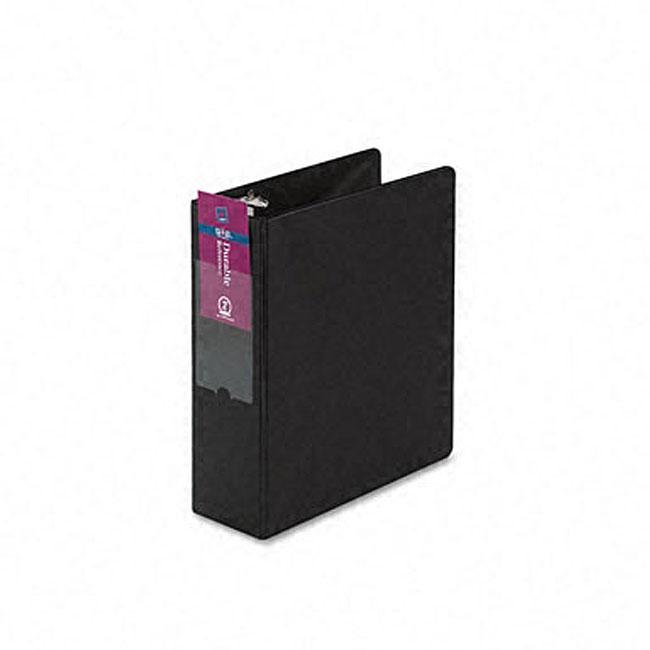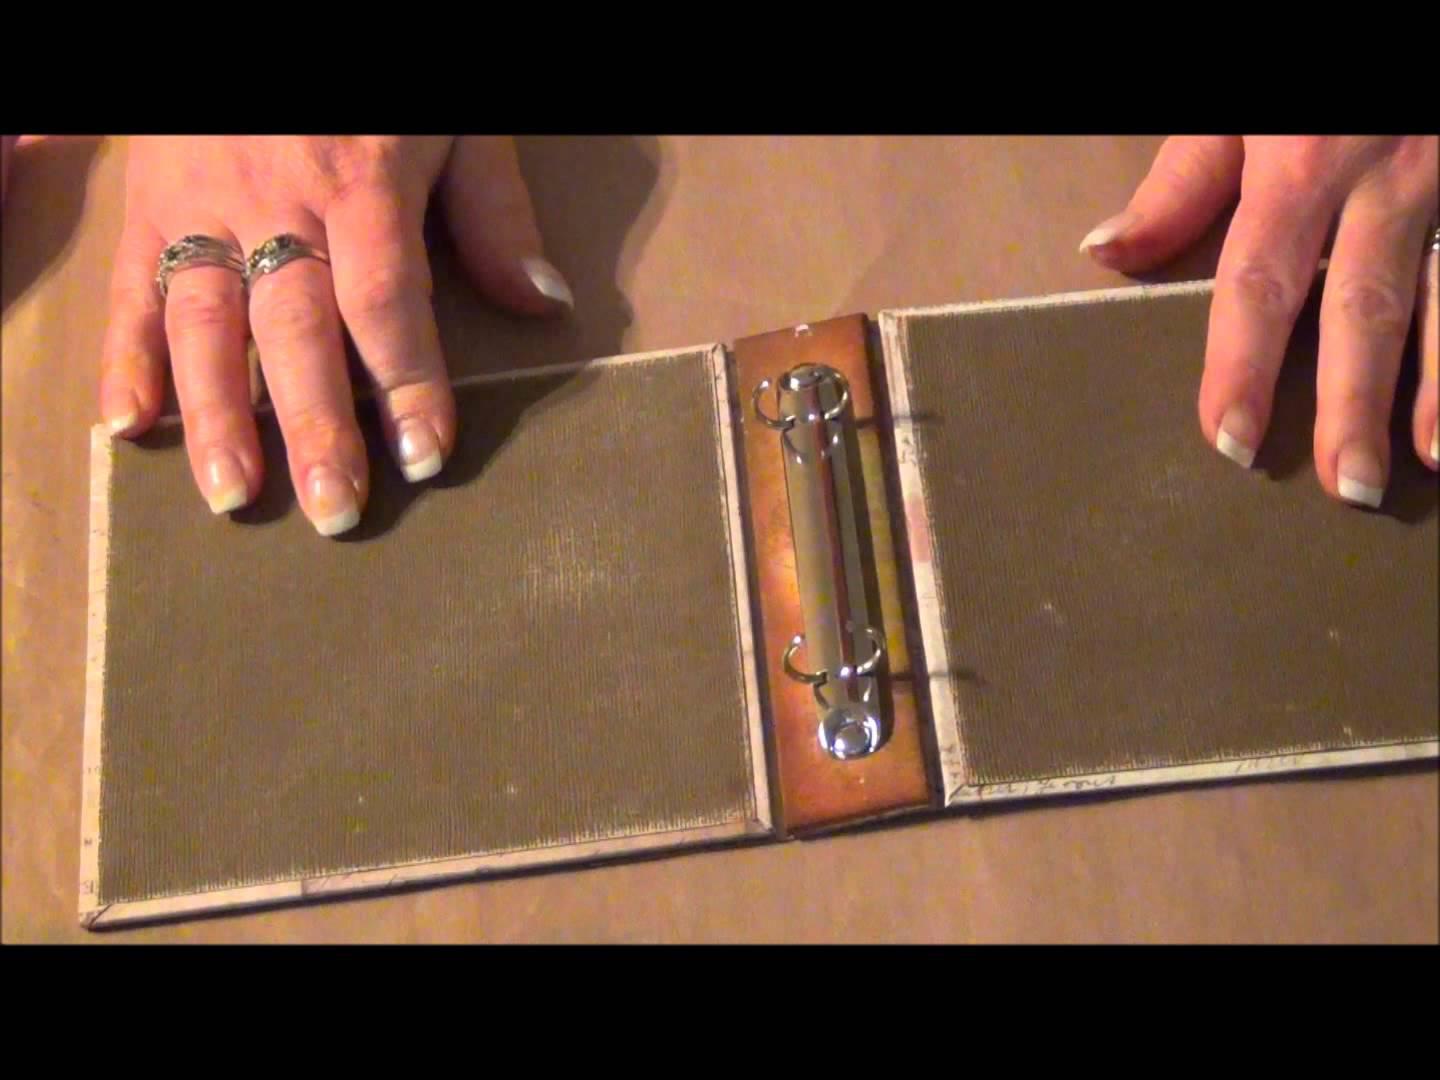The first image is the image on the left, the second image is the image on the right. For the images displayed, is the sentence "An image includes a black upright binder with a black circle below a white rectangle on its end." factually correct? Answer yes or no. No. The first image is the image on the left, the second image is the image on the right. Assess this claim about the two images: "There are two black binders on a wooden surface.". Correct or not? Answer yes or no. No. 